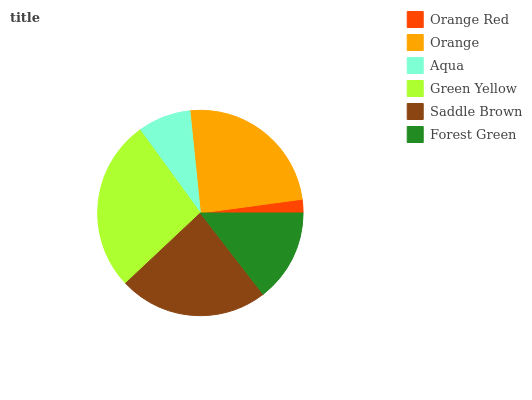Is Orange Red the minimum?
Answer yes or no. Yes. Is Green Yellow the maximum?
Answer yes or no. Yes. Is Orange the minimum?
Answer yes or no. No. Is Orange the maximum?
Answer yes or no. No. Is Orange greater than Orange Red?
Answer yes or no. Yes. Is Orange Red less than Orange?
Answer yes or no. Yes. Is Orange Red greater than Orange?
Answer yes or no. No. Is Orange less than Orange Red?
Answer yes or no. No. Is Saddle Brown the high median?
Answer yes or no. Yes. Is Forest Green the low median?
Answer yes or no. Yes. Is Aqua the high median?
Answer yes or no. No. Is Orange the low median?
Answer yes or no. No. 